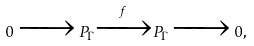<formula> <loc_0><loc_0><loc_500><loc_500>0 \xrightarrow { \quad } P _ { \Gamma } { \xrightarrow { \ f \ } } P _ { \Gamma } \xrightarrow { \quad } 0 ,</formula> 